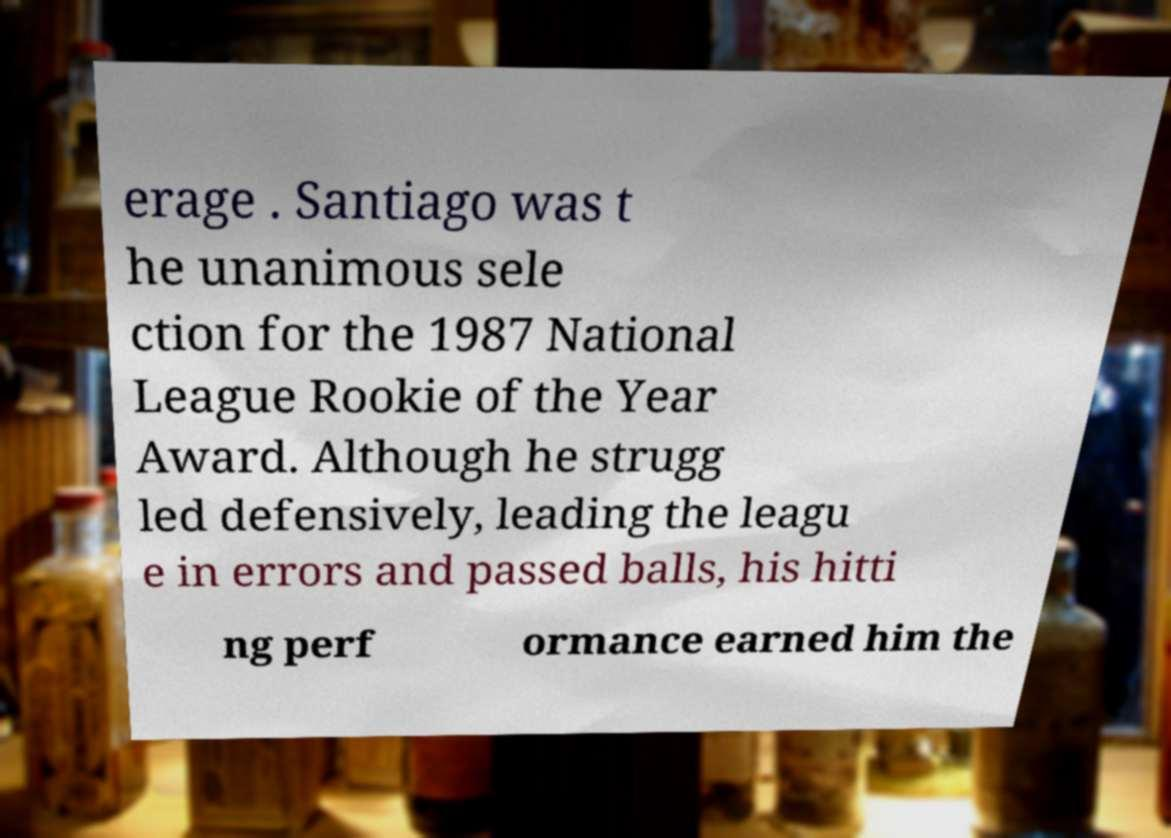For documentation purposes, I need the text within this image transcribed. Could you provide that? erage . Santiago was t he unanimous sele ction for the 1987 National League Rookie of the Year Award. Although he strugg led defensively, leading the leagu e in errors and passed balls, his hitti ng perf ormance earned him the 